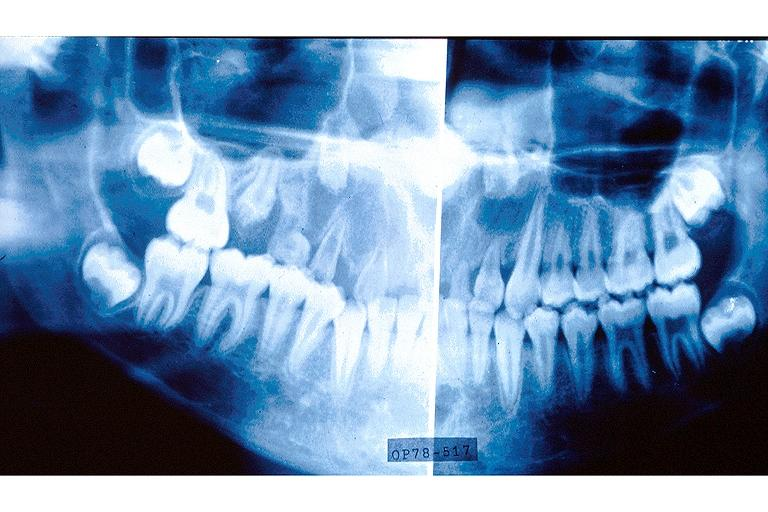what is present?
Answer the question using a single word or phrase. Oral 